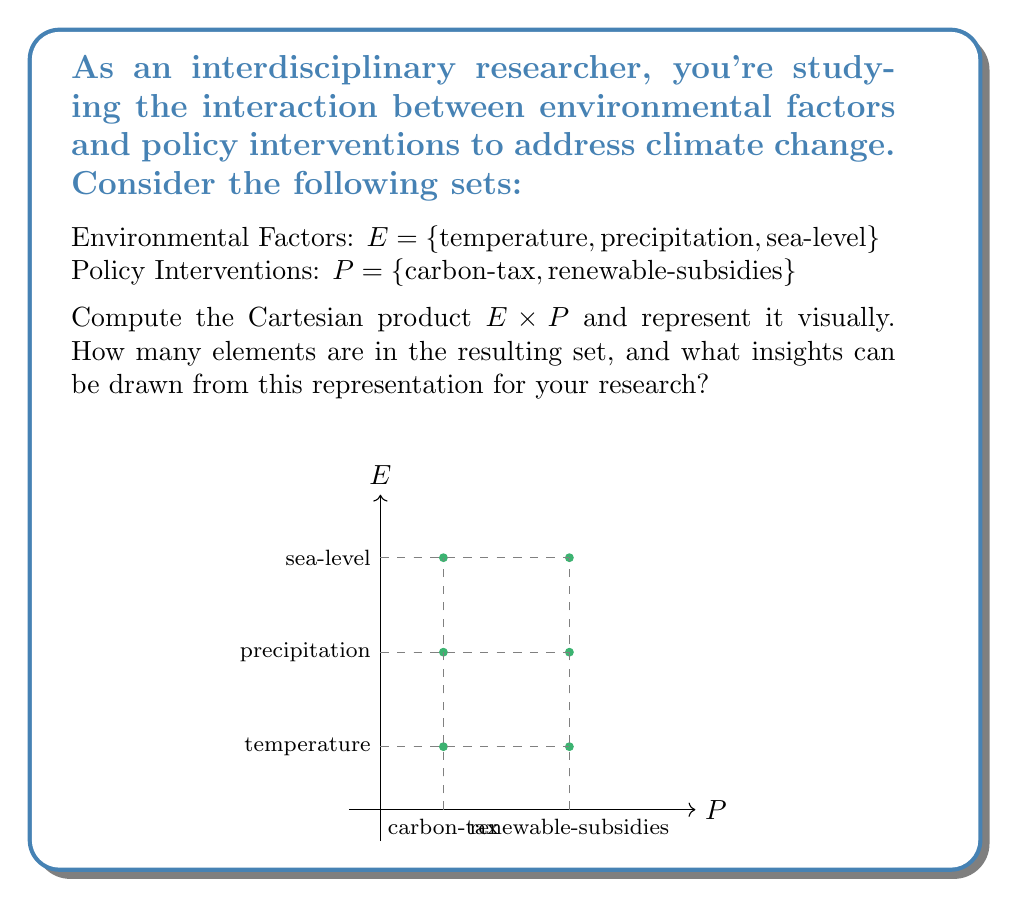What is the answer to this math problem? To solve this problem, let's follow these steps:

1) The Cartesian product of two sets $A$ and $B$ is defined as:
   $$A \times B = \{(a,b) | a \in A \text{ and } b \in B\}$$

2) In this case, we're computing $E \times P$, where:
   $E = \{temperature, precipitation, sea\text{-}level\}$
   $P = \{carbon\text{-}tax, renewable\text{-}subsidies\}$

3) To form $E \times P$, we pair each element of $E$ with each element of $P$:

   $E \times P = \{$
   $(temperature, carbon\text{-}tax),$
   $(temperature, renewable\text{-}subsidies),$
   $(precipitation, carbon\text{-}tax),$
   $(precipitation, renewable\text{-}subsidies),$
   $(sea\text{-}level, carbon\text{-}tax),$
   $(sea\text{-}level, renewable\text{-}subsidies)$
   $\}$

4) The number of elements in the Cartesian product is the product of the number of elements in each set:
   $|E \times P| = |E| \times |P| = 3 \times 2 = 6$

5) The visual representation in the question shows these pairs as points on a grid, where the x-axis represents policy interventions and the y-axis represents environmental factors.

6) Insights for research:
   - This representation allows for systematic exploration of how each policy intervention might affect each environmental factor.
   - It provides a framework for analyzing potential cross-impacts and interactions between different policy-environment pairs.
   - The Cartesian product ensures all possible combinations are considered, reducing the risk of overlooking important interactions in the research.
Answer: $E \times P = \{(temperature, carbon\text{-}tax), (temperature, renewable\text{-}subsidies), (precipitation, carbon\text{-}tax), (precipitation, renewable\text{-}subsidies), (sea\text{-}level, carbon\text{-}tax), (sea\text{-}level, renewable\text{-}subsidies)\}$; $|E \times P| = 6$ 